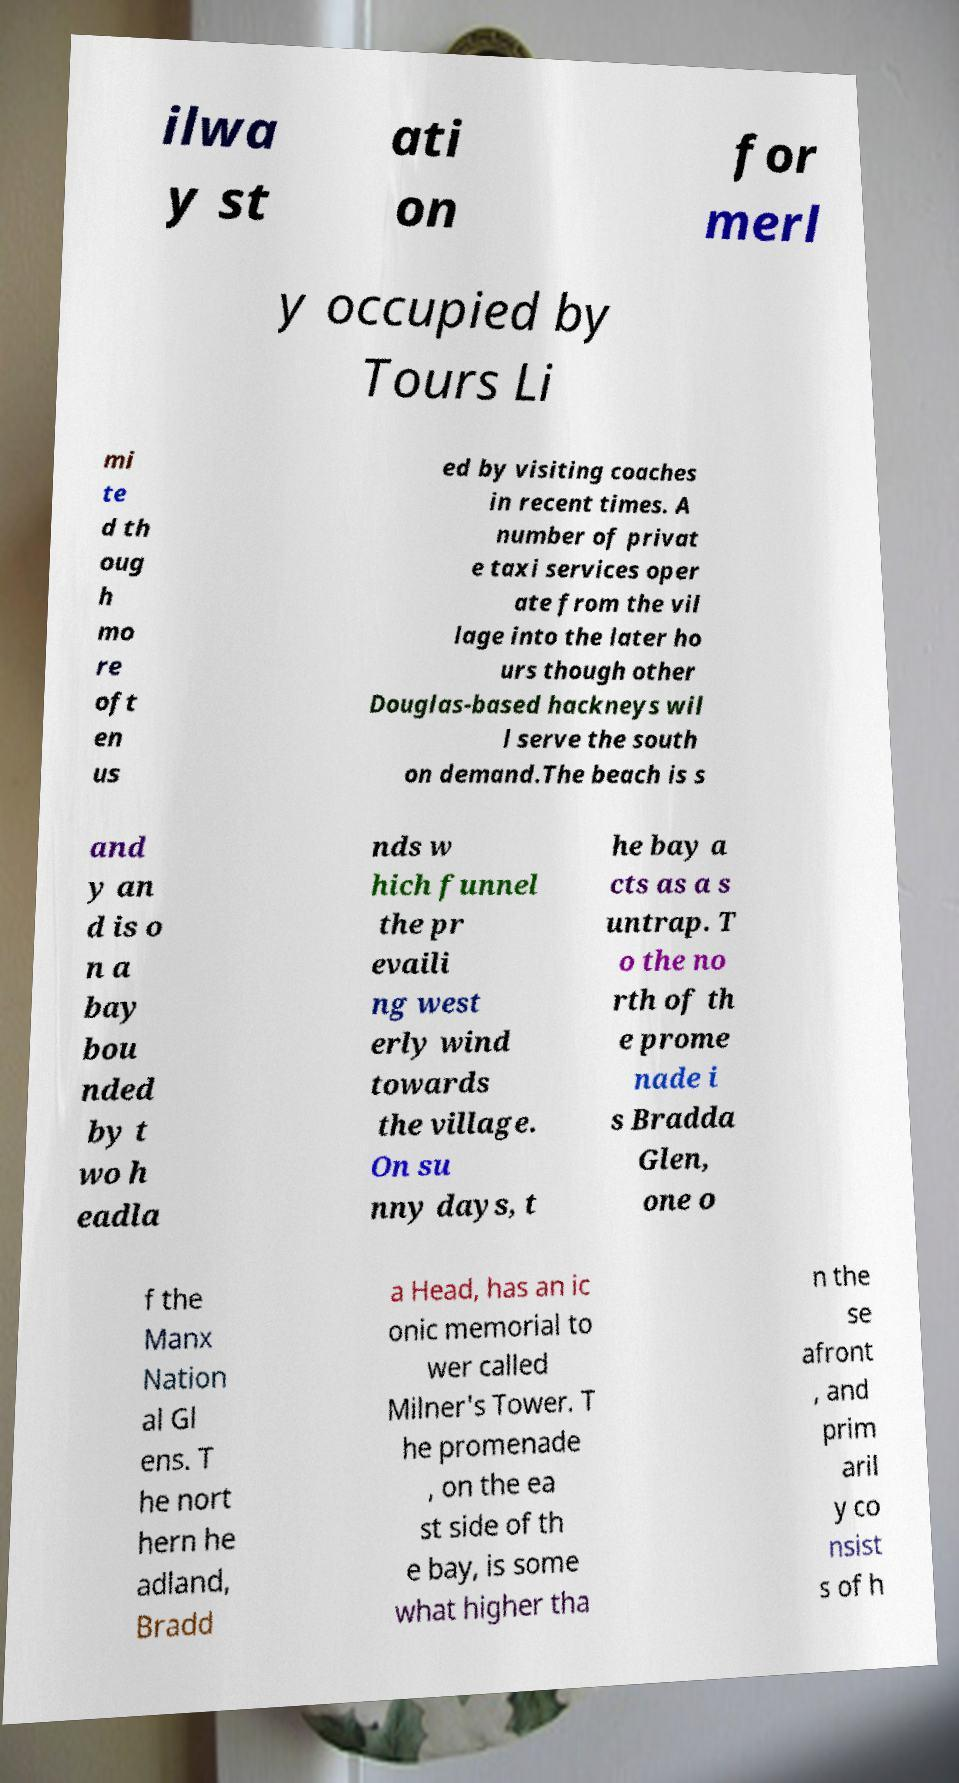Could you extract and type out the text from this image? ilwa y st ati on for merl y occupied by Tours Li mi te d th oug h mo re oft en us ed by visiting coaches in recent times. A number of privat e taxi services oper ate from the vil lage into the later ho urs though other Douglas-based hackneys wil l serve the south on demand.The beach is s and y an d is o n a bay bou nded by t wo h eadla nds w hich funnel the pr evaili ng west erly wind towards the village. On su nny days, t he bay a cts as a s untrap. T o the no rth of th e prome nade i s Bradda Glen, one o f the Manx Nation al Gl ens. T he nort hern he adland, Bradd a Head, has an ic onic memorial to wer called Milner's Tower. T he promenade , on the ea st side of th e bay, is some what higher tha n the se afront , and prim aril y co nsist s of h 